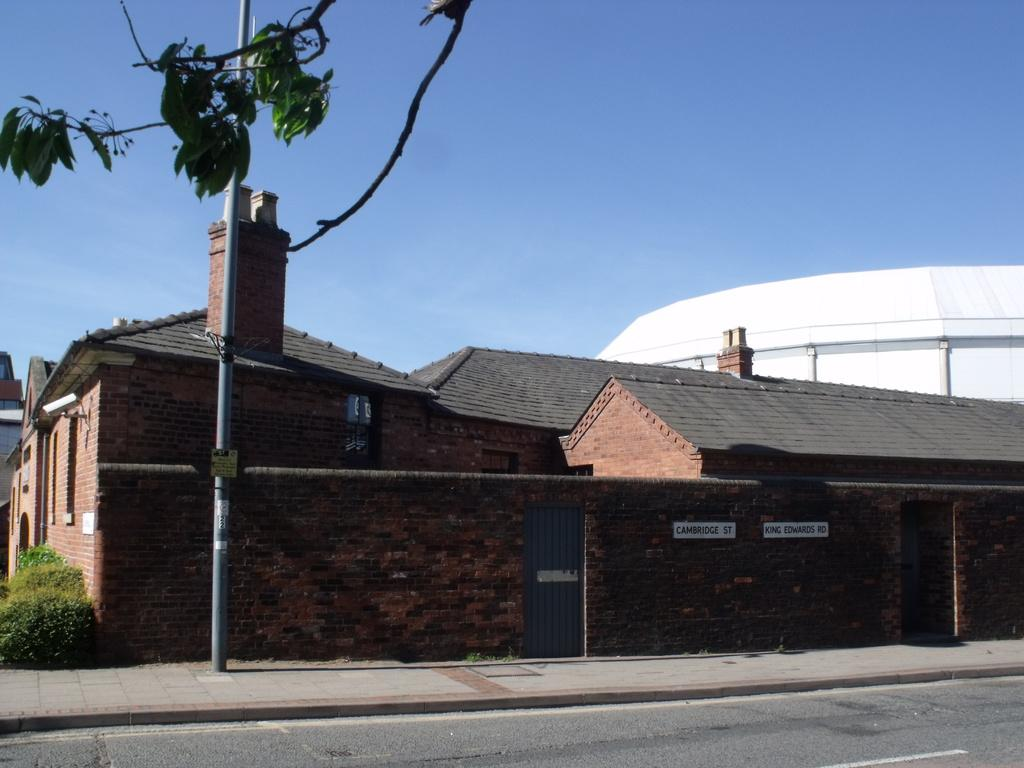What type of building can be seen in the image? There is a building made of bricks in the image. What is located in front of the building? There is a pole in front of the building. What is at the bottom of the image? There is a road at the bottom of the image. What can be seen in the background of the image? The sky is visible in the background of the image. What type of meat is hanging from the pole in the image? There is no meat present in the image; the pole is empty. 